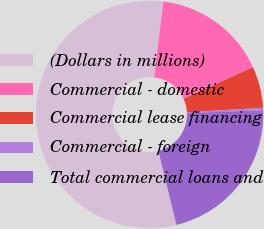Convert chart to OTSL. <chart><loc_0><loc_0><loc_500><loc_500><pie_chart><fcel>(Dollars in millions)<fcel>Commercial - domestic<fcel>Commercial lease financing<fcel>Commercial - foreign<fcel>Total commercial loans and<nl><fcel>55.74%<fcel>16.23%<fcel>5.9%<fcel>0.36%<fcel>21.77%<nl></chart> 